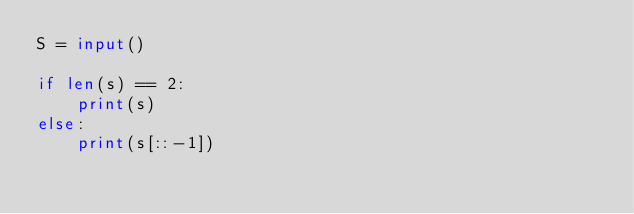<code> <loc_0><loc_0><loc_500><loc_500><_Python_>S = input()

if len(s) == 2:
    print(s)
else:
    print(s[::-1])</code> 